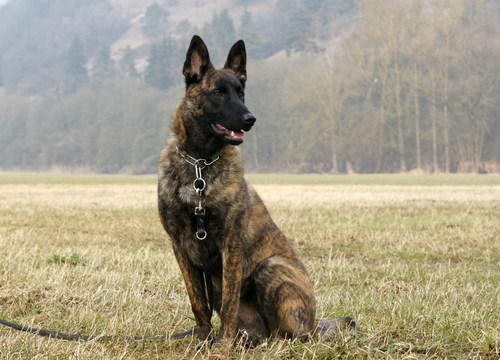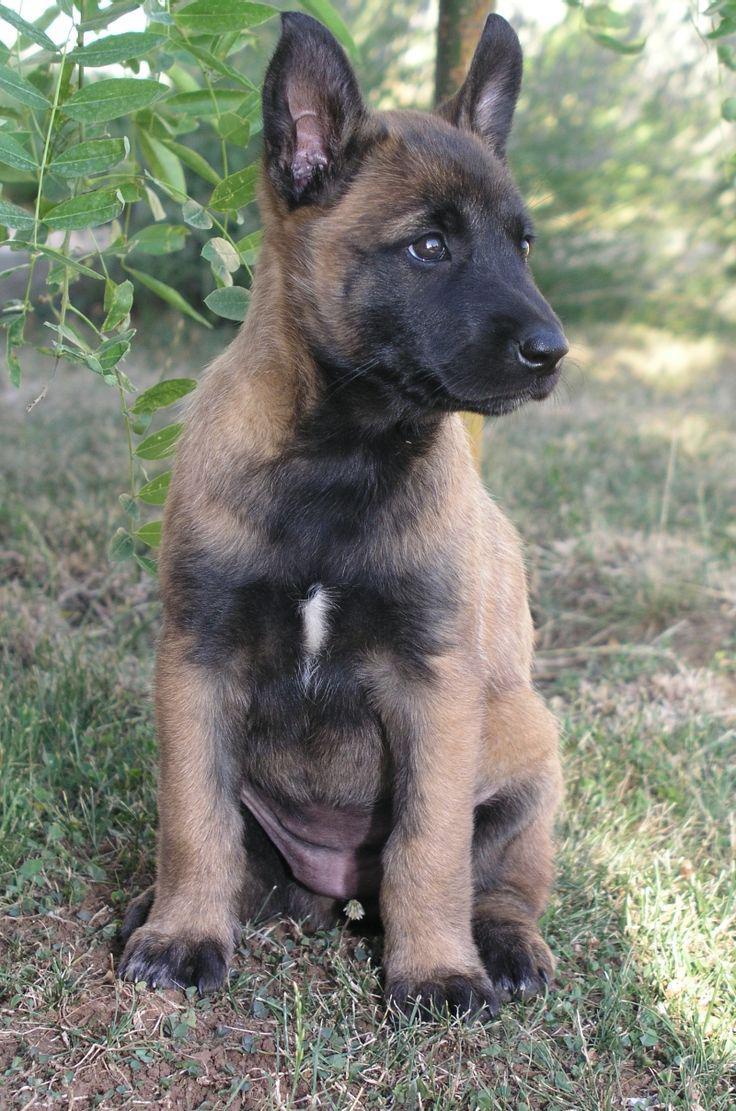The first image is the image on the left, the second image is the image on the right. Given the left and right images, does the statement "The dog in the left image is attached to a leash." hold true? Answer yes or no. Yes. The first image is the image on the left, the second image is the image on the right. Given the left and right images, does the statement "At least one dog is sitting in the grass." hold true? Answer yes or no. Yes. 